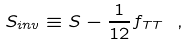Convert formula to latex. <formula><loc_0><loc_0><loc_500><loc_500>S _ { i n v } \equiv S - { \frac { 1 } { 1 2 } } f _ { T T } \ ,</formula> 